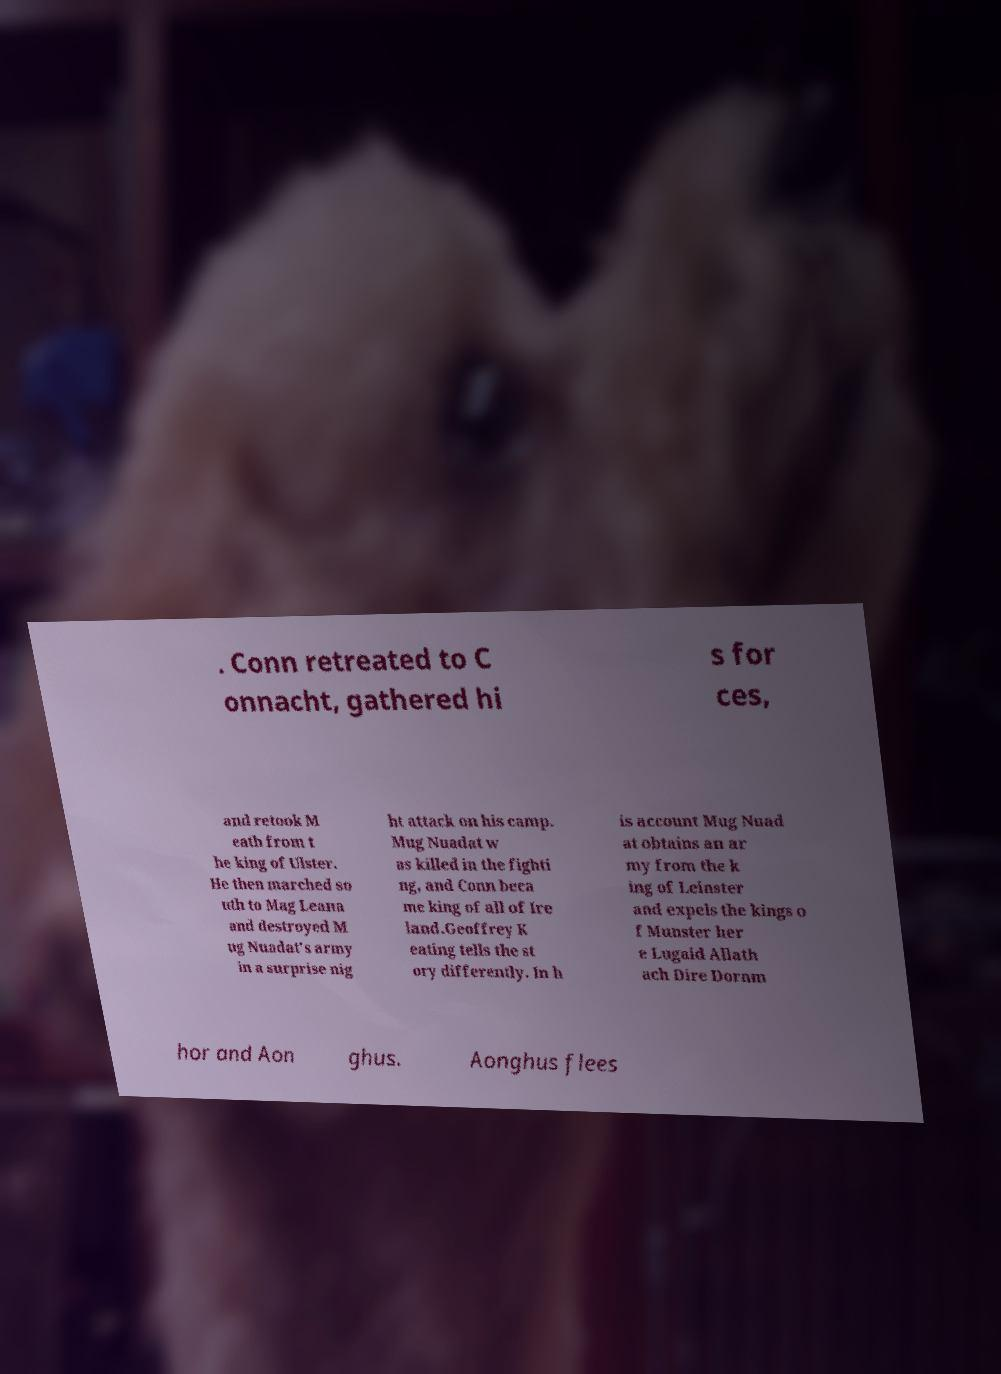Please identify and transcribe the text found in this image. . Conn retreated to C onnacht, gathered hi s for ces, and retook M eath from t he king of Ulster. He then marched so uth to Mag Leana and destroyed M ug Nuadat's army in a surprise nig ht attack on his camp. Mug Nuadat w as killed in the fighti ng, and Conn beca me king of all of Ire land.Geoffrey K eating tells the st ory differently. In h is account Mug Nuad at obtains an ar my from the k ing of Leinster and expels the kings o f Munster her e Lugaid Allath ach Dire Dornm hor and Aon ghus. Aonghus flees 